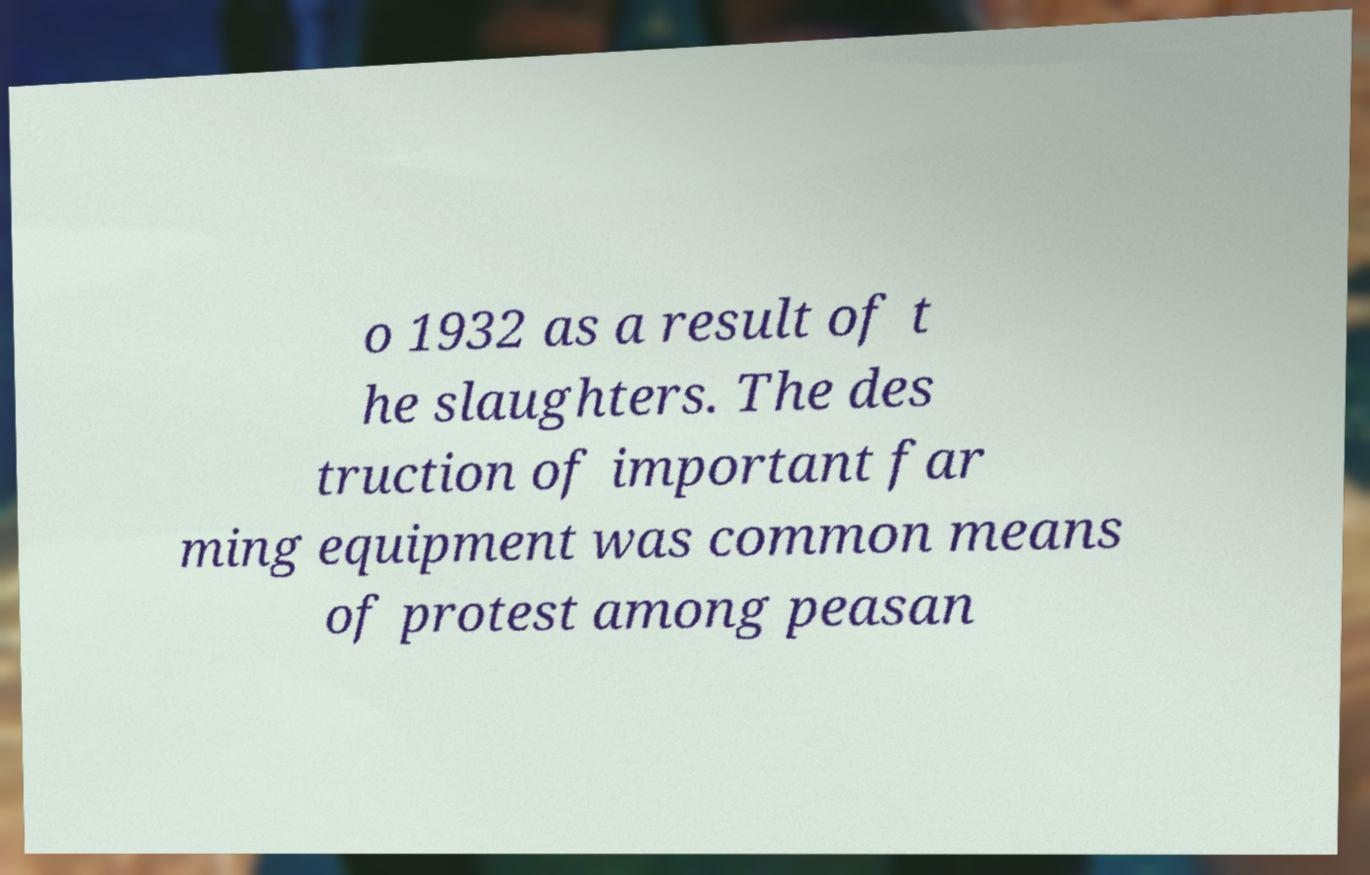Please read and relay the text visible in this image. What does it say? o 1932 as a result of t he slaughters. The des truction of important far ming equipment was common means of protest among peasan 